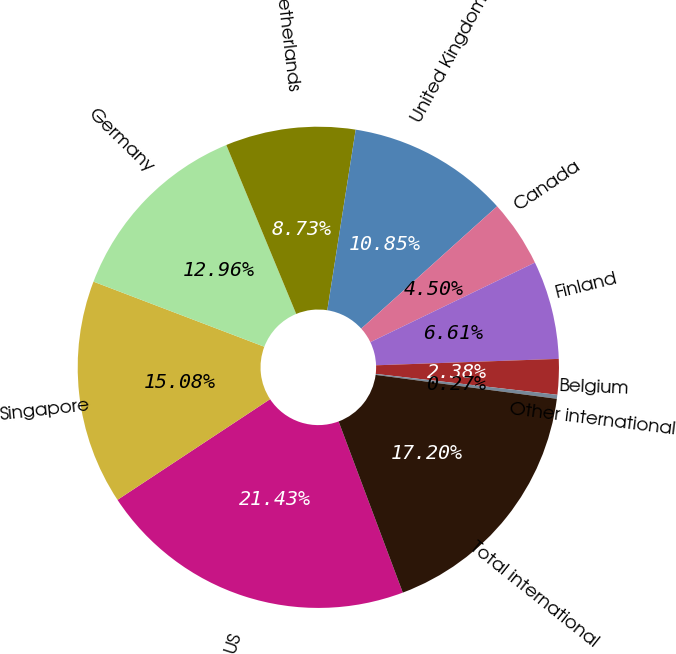Convert chart to OTSL. <chart><loc_0><loc_0><loc_500><loc_500><pie_chart><fcel>US<fcel>Singapore<fcel>Germany<fcel>Netherlands<fcel>United Kingdom<fcel>Canada<fcel>Finland<fcel>Belgium<fcel>Other international<fcel>Total international<nl><fcel>21.43%<fcel>15.08%<fcel>12.96%<fcel>8.73%<fcel>10.85%<fcel>4.5%<fcel>6.61%<fcel>2.38%<fcel>0.27%<fcel>17.2%<nl></chart> 